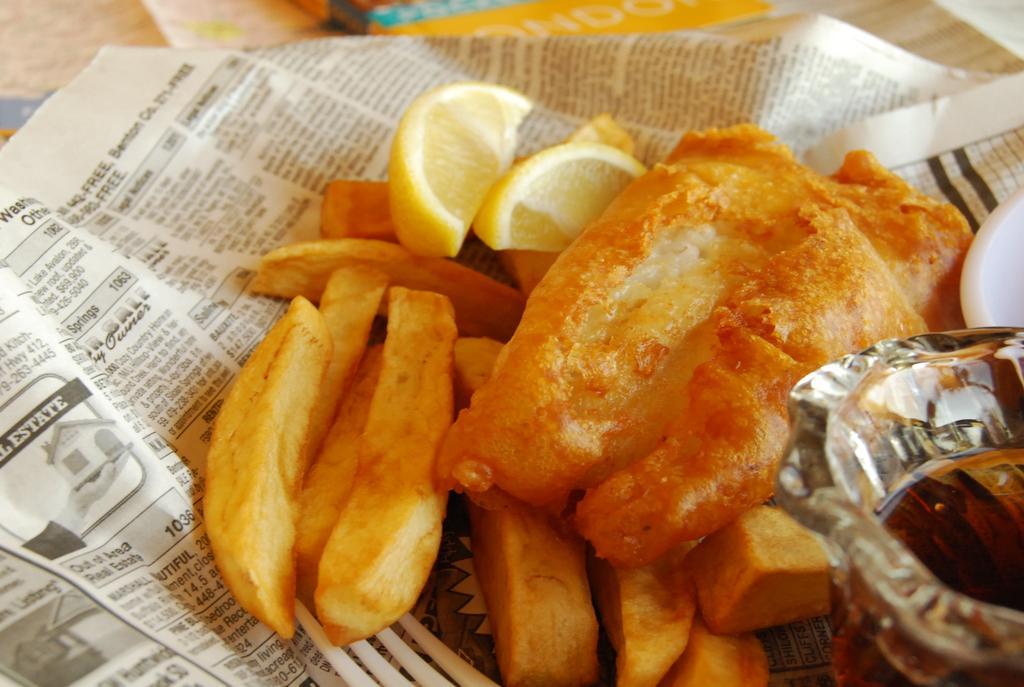<image>
Describe the image concisely. Fish and chips rest on a sheet of newspaper that is the real estate section. 